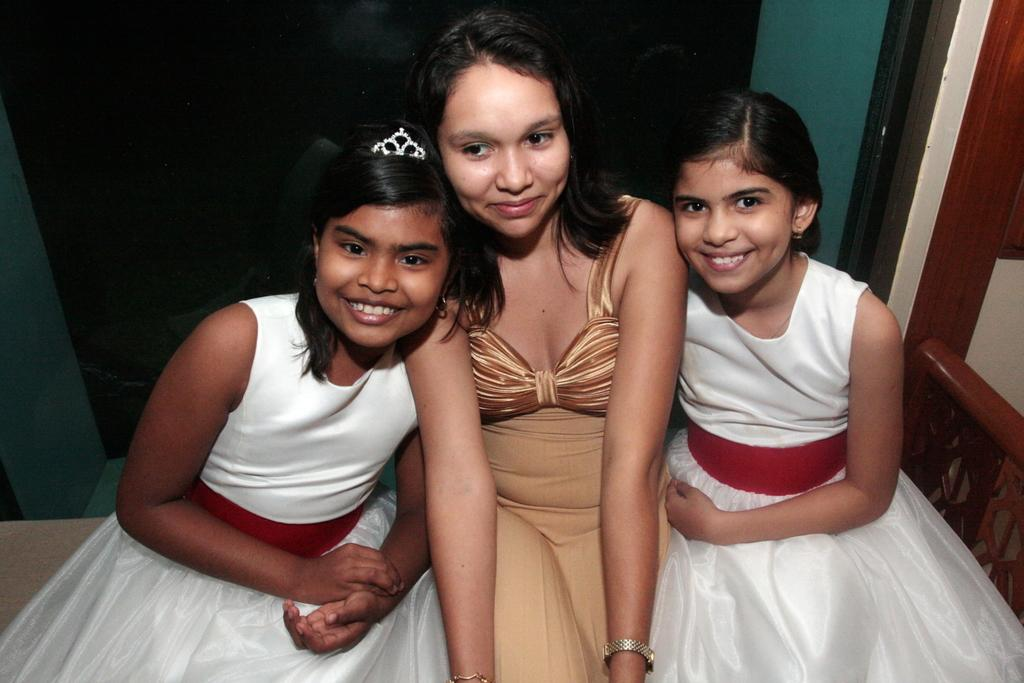What are the people in the image doing? The persons in the image are sitting on a bench. What can be seen in the background of the image? There is a wall and a curtain in the background of the image. How many rabbits are hopping on the bench in the image? There are no rabbits present in the image; it features persons sitting on a bench. Can you tell me how many frogs are sitting on the curtain in the image? There are no frogs present in the image; it features a wall and a curtain in the background. 